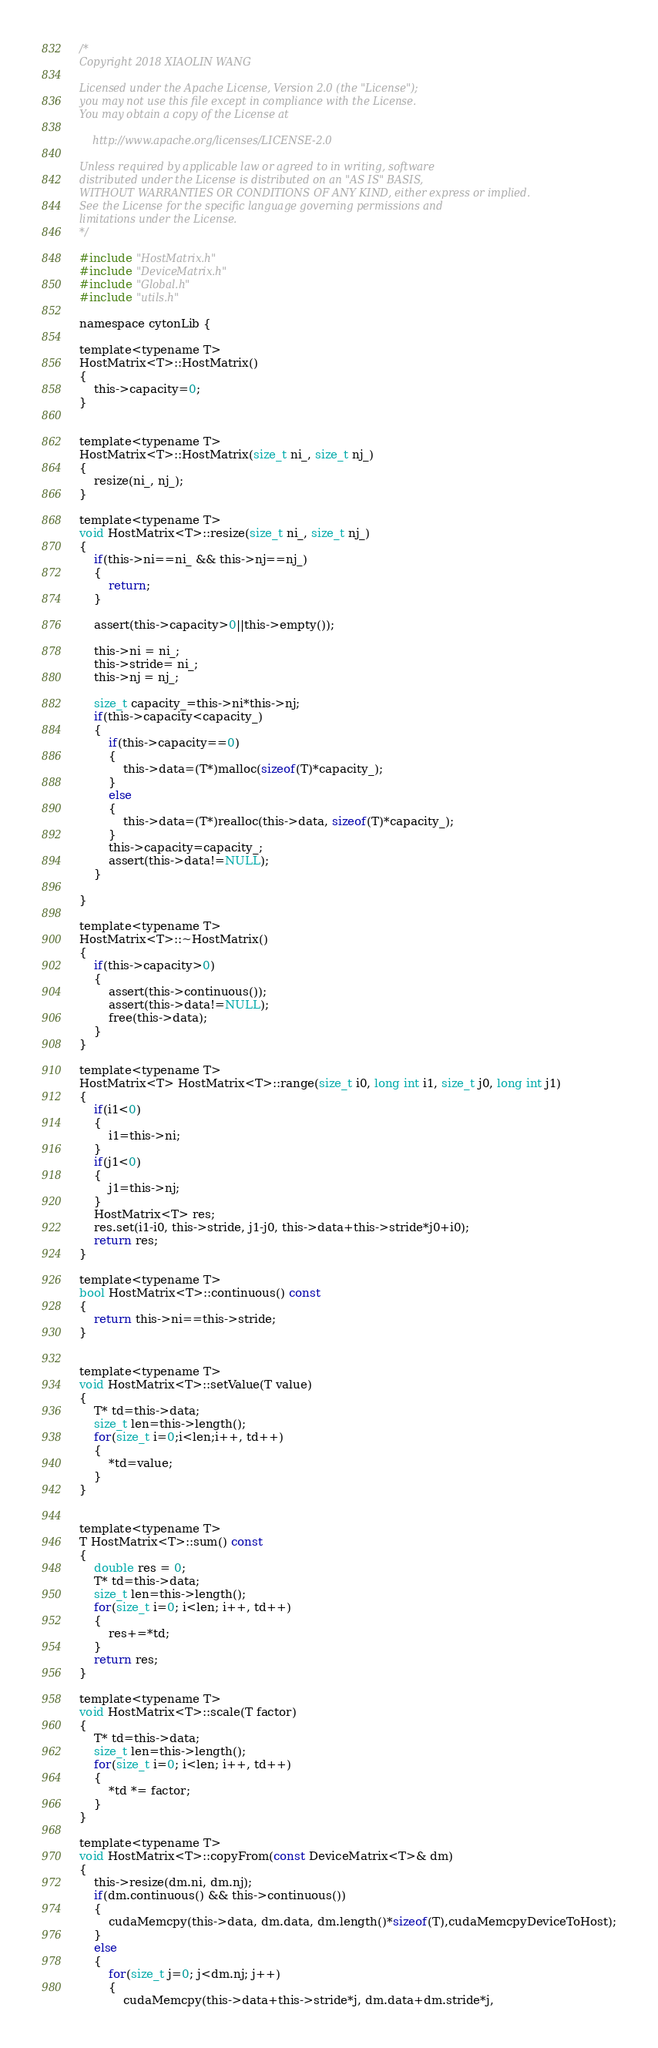<code> <loc_0><loc_0><loc_500><loc_500><_Cuda_>/*
Copyright 2018 XIAOLIN WANG 

Licensed under the Apache License, Version 2.0 (the "License");
you may not use this file except in compliance with the License.
You may obtain a copy of the License at

    http://www.apache.org/licenses/LICENSE-2.0

Unless required by applicable law or agreed to in writing, software
distributed under the License is distributed on an "AS IS" BASIS,
WITHOUT WARRANTIES OR CONDITIONS OF ANY KIND, either express or implied.
See the License for the specific language governing permissions and
limitations under the License.
*/

#include "HostMatrix.h"
#include "DeviceMatrix.h"
#include "Global.h"
#include "utils.h"

namespace cytonLib {

template<typename T>
HostMatrix<T>::HostMatrix()
{
	this->capacity=0;
}


template<typename T>
HostMatrix<T>::HostMatrix(size_t ni_, size_t nj_)
{
	resize(ni_, nj_);
}

template<typename T>
void HostMatrix<T>::resize(size_t ni_, size_t nj_)
{
	if(this->ni==ni_ && this->nj==nj_)
	{
		return;
	}

	assert(this->capacity>0||this->empty());

	this->ni = ni_;
	this->stride= ni_;
	this->nj = nj_;

	size_t capacity_=this->ni*this->nj;
	if(this->capacity<capacity_)
	{
		if(this->capacity==0)
		{
			this->data=(T*)malloc(sizeof(T)*capacity_);
		}
		else
		{
			this->data=(T*)realloc(this->data, sizeof(T)*capacity_);
		}
		this->capacity=capacity_;
		assert(this->data!=NULL);
	}

}

template<typename T>
HostMatrix<T>::~HostMatrix()
{
	if(this->capacity>0)
	{
		assert(this->continuous());
		assert(this->data!=NULL);
		free(this->data);
	}
}

template<typename T>
HostMatrix<T> HostMatrix<T>::range(size_t i0, long int i1, size_t j0, long int j1)
{
	if(i1<0)
	{
		i1=this->ni;
	}
	if(j1<0)
	{
		j1=this->nj;
	}
	HostMatrix<T> res;
	res.set(i1-i0, this->stride, j1-j0, this->data+this->stride*j0+i0);
	return res;
}

template<typename T>
bool HostMatrix<T>::continuous() const
{
	return this->ni==this->stride;
}


template<typename T>
void HostMatrix<T>::setValue(T value)
{
	T* td=this->data;
	size_t len=this->length();
	for(size_t i=0;i<len;i++, td++)
	{
		*td=value;
	}
}


template<typename T>
T HostMatrix<T>::sum() const
{
	double res = 0;
	T* td=this->data;
	size_t len=this->length();
	for(size_t i=0; i<len; i++, td++)
	{
		res+=*td;
	}
	return res;
}

template<typename T>
void HostMatrix<T>::scale(T factor)
{
	T* td=this->data;
	size_t len=this->length();
	for(size_t i=0; i<len; i++, td++)
	{
		*td *= factor;
	}
}

template<typename T>
void HostMatrix<T>::copyFrom(const DeviceMatrix<T>& dm)
{
	this->resize(dm.ni, dm.nj);
	if(dm.continuous() && this->continuous())
	{
		cudaMemcpy(this->data, dm.data, dm.length()*sizeof(T),cudaMemcpyDeviceToHost);
	}
	else
	{
		for(size_t j=0; j<dm.nj; j++)
		{
			cudaMemcpy(this->data+this->stride*j, dm.data+dm.stride*j,</code> 